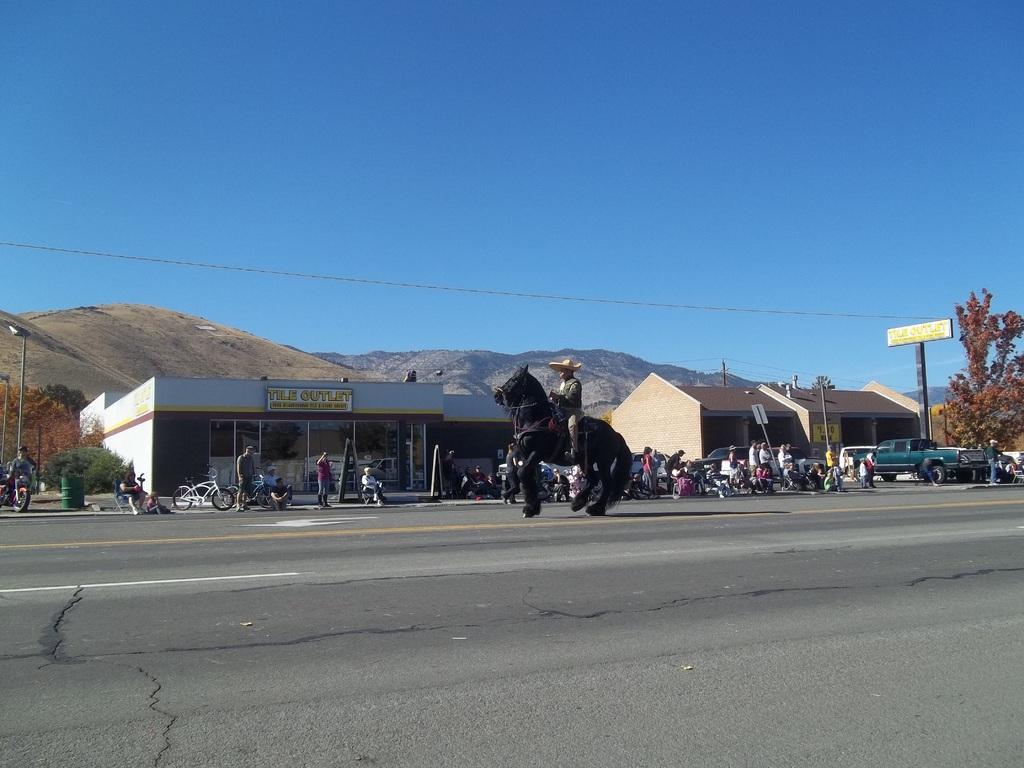In one or two sentences, can you explain what this image depicts? In this image there are seeds and trees. We can see vehicles on the road and there are people. There is a person sitting on the horse. There is a board. In the background we can see hills and there is sky. 